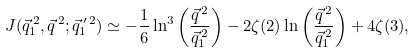Convert formula to latex. <formula><loc_0><loc_0><loc_500><loc_500>J ( \vec { q } _ { 1 } ^ { \, 2 } , \vec { q } ^ { \, 2 } ; \vec { q } _ { 1 } ^ { \, \prime \, 2 } ) \simeq - \frac { 1 } { 6 } \ln ^ { 3 } \left ( \frac { \vec { q } ^ { \, 2 } } { \vec { q } _ { 1 } ^ { \, 2 } } \right ) - 2 \zeta ( 2 ) \ln \left ( \frac { \vec { q } ^ { \, 2 } } { \vec { q } _ { 1 } ^ { \, 2 } } \right ) + 4 \zeta ( 3 ) ,</formula> 